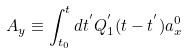<formula> <loc_0><loc_0><loc_500><loc_500>A _ { y } \equiv \int _ { t _ { 0 } } ^ { t } d t ^ { ^ { \prime } } Q _ { 1 } ^ { ^ { \prime } } ( t - t ^ { ^ { \prime } } ) a _ { x } ^ { 0 }</formula> 